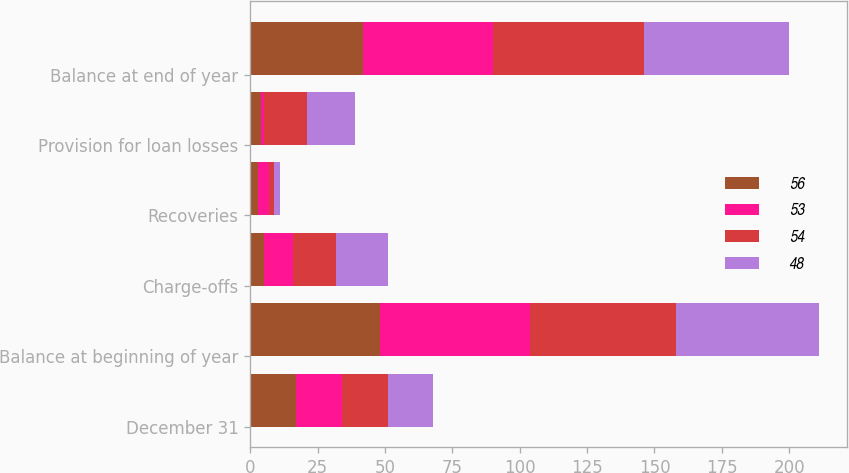Convert chart to OTSL. <chart><loc_0><loc_0><loc_500><loc_500><stacked_bar_chart><ecel><fcel>December 31<fcel>Balance at beginning of year<fcel>Charge-offs<fcel>Recoveries<fcel>Provision for loan losses<fcel>Balance at end of year<nl><fcel>56<fcel>17<fcel>48<fcel>5<fcel>3<fcel>4<fcel>42<nl><fcel>53<fcel>17<fcel>56<fcel>11<fcel>4<fcel>1<fcel>48<nl><fcel>54<fcel>17<fcel>54<fcel>16<fcel>2<fcel>16<fcel>56<nl><fcel>48<fcel>17<fcel>53<fcel>19<fcel>2<fcel>18<fcel>54<nl></chart> 